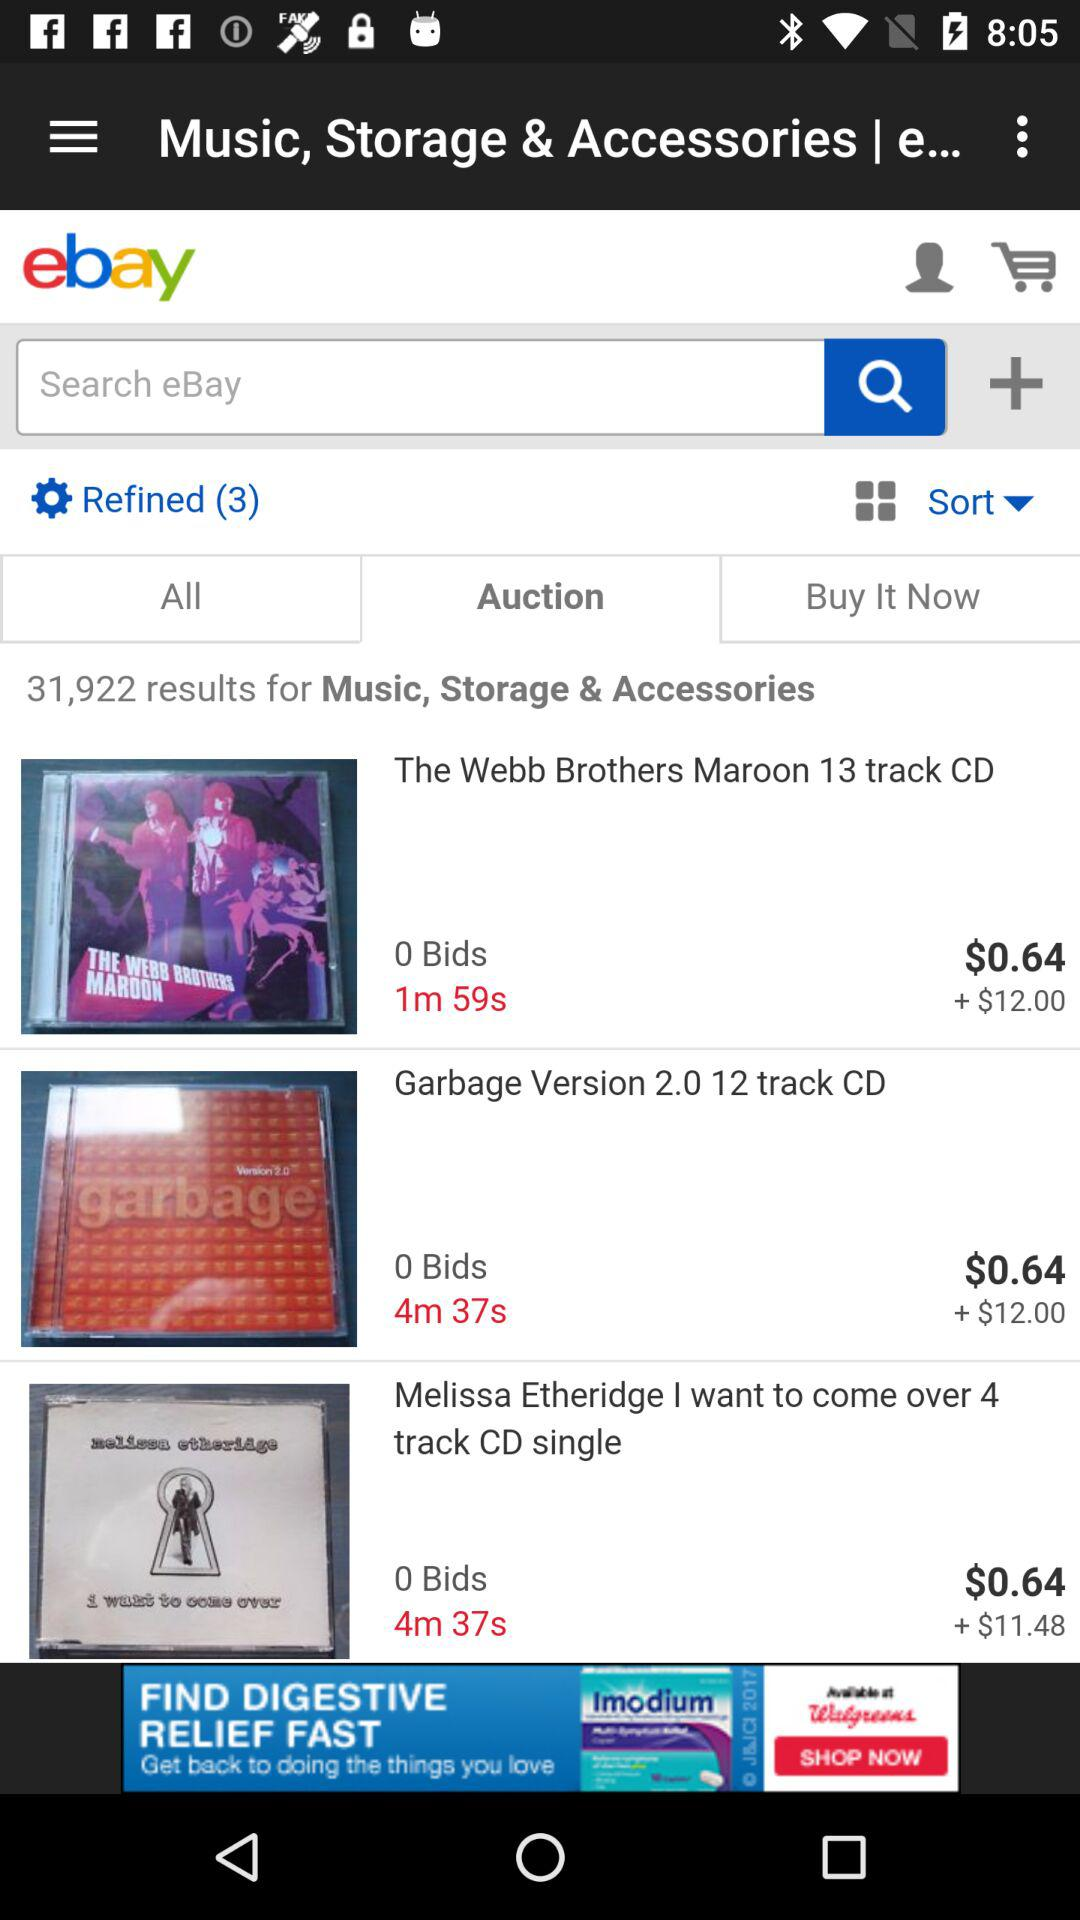What is the time left to place a bid for "The Webb Brothers Maroon 13 track CD"? The time left to place a bid for "The Webb Brothers Maroon 13 track CD" is 1 minute 59 seconds. 